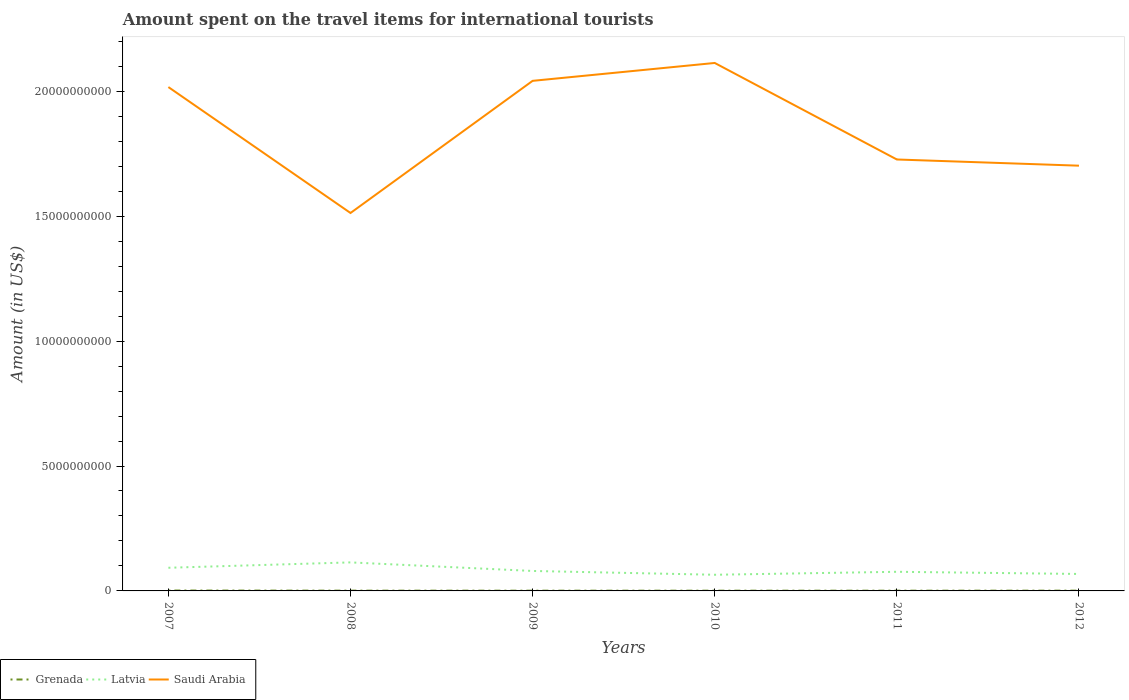Is the number of lines equal to the number of legend labels?
Ensure brevity in your answer.  Yes. Across all years, what is the maximum amount spent on the travel items for international tourists in Latvia?
Your response must be concise. 6.47e+08. In which year was the amount spent on the travel items for international tourists in Latvia maximum?
Provide a short and direct response. 2010. What is the total amount spent on the travel items for international tourists in Saudi Arabia in the graph?
Your response must be concise. -6.01e+09. What is the difference between the highest and the second highest amount spent on the travel items for international tourists in Grenada?
Offer a very short reply. 6.00e+06. What is the difference between the highest and the lowest amount spent on the travel items for international tourists in Grenada?
Your response must be concise. 1. How many lines are there?
Provide a short and direct response. 3. How many years are there in the graph?
Provide a short and direct response. 6. What is the difference between two consecutive major ticks on the Y-axis?
Your answer should be very brief. 5.00e+09. Are the values on the major ticks of Y-axis written in scientific E-notation?
Your answer should be compact. No. Does the graph contain any zero values?
Give a very brief answer. No. What is the title of the graph?
Offer a very short reply. Amount spent on the travel items for international tourists. What is the label or title of the X-axis?
Offer a terse response. Years. What is the label or title of the Y-axis?
Make the answer very short. Amount (in US$). What is the Amount (in US$) of Grenada in 2007?
Offer a very short reply. 1.60e+07. What is the Amount (in US$) in Latvia in 2007?
Ensure brevity in your answer.  9.27e+08. What is the Amount (in US$) in Saudi Arabia in 2007?
Give a very brief answer. 2.02e+1. What is the Amount (in US$) in Grenada in 2008?
Your answer should be compact. 1.10e+07. What is the Amount (in US$) of Latvia in 2008?
Offer a very short reply. 1.14e+09. What is the Amount (in US$) in Saudi Arabia in 2008?
Provide a succinct answer. 1.51e+1. What is the Amount (in US$) of Latvia in 2009?
Your answer should be very brief. 7.99e+08. What is the Amount (in US$) of Saudi Arabia in 2009?
Offer a very short reply. 2.04e+1. What is the Amount (in US$) in Latvia in 2010?
Keep it short and to the point. 6.47e+08. What is the Amount (in US$) in Saudi Arabia in 2010?
Provide a short and direct response. 2.11e+1. What is the Amount (in US$) in Latvia in 2011?
Ensure brevity in your answer.  7.66e+08. What is the Amount (in US$) of Saudi Arabia in 2011?
Your answer should be very brief. 1.73e+1. What is the Amount (in US$) of Grenada in 2012?
Your answer should be very brief. 1.10e+07. What is the Amount (in US$) of Latvia in 2012?
Ensure brevity in your answer.  6.79e+08. What is the Amount (in US$) of Saudi Arabia in 2012?
Your answer should be very brief. 1.70e+1. Across all years, what is the maximum Amount (in US$) of Grenada?
Keep it short and to the point. 1.60e+07. Across all years, what is the maximum Amount (in US$) in Latvia?
Offer a very short reply. 1.14e+09. Across all years, what is the maximum Amount (in US$) in Saudi Arabia?
Keep it short and to the point. 2.11e+1. Across all years, what is the minimum Amount (in US$) of Grenada?
Give a very brief answer. 1.00e+07. Across all years, what is the minimum Amount (in US$) of Latvia?
Your answer should be very brief. 6.47e+08. Across all years, what is the minimum Amount (in US$) in Saudi Arabia?
Give a very brief answer. 1.51e+1. What is the total Amount (in US$) of Grenada in the graph?
Your answer should be very brief. 6.80e+07. What is the total Amount (in US$) of Latvia in the graph?
Provide a short and direct response. 4.96e+09. What is the total Amount (in US$) in Saudi Arabia in the graph?
Your response must be concise. 1.11e+11. What is the difference between the Amount (in US$) in Grenada in 2007 and that in 2008?
Your answer should be very brief. 5.00e+06. What is the difference between the Amount (in US$) of Latvia in 2007 and that in 2008?
Offer a very short reply. -2.15e+08. What is the difference between the Amount (in US$) of Saudi Arabia in 2007 and that in 2008?
Give a very brief answer. 5.04e+09. What is the difference between the Amount (in US$) in Latvia in 2007 and that in 2009?
Make the answer very short. 1.28e+08. What is the difference between the Amount (in US$) in Saudi Arabia in 2007 and that in 2009?
Your response must be concise. -2.49e+08. What is the difference between the Amount (in US$) in Grenada in 2007 and that in 2010?
Provide a short and direct response. 6.00e+06. What is the difference between the Amount (in US$) in Latvia in 2007 and that in 2010?
Give a very brief answer. 2.80e+08. What is the difference between the Amount (in US$) in Saudi Arabia in 2007 and that in 2010?
Offer a very short reply. -9.65e+08. What is the difference between the Amount (in US$) of Grenada in 2007 and that in 2011?
Your answer should be compact. 6.00e+06. What is the difference between the Amount (in US$) in Latvia in 2007 and that in 2011?
Offer a very short reply. 1.61e+08. What is the difference between the Amount (in US$) of Saudi Arabia in 2007 and that in 2011?
Give a very brief answer. 2.90e+09. What is the difference between the Amount (in US$) in Grenada in 2007 and that in 2012?
Your answer should be very brief. 5.00e+06. What is the difference between the Amount (in US$) in Latvia in 2007 and that in 2012?
Give a very brief answer. 2.48e+08. What is the difference between the Amount (in US$) in Saudi Arabia in 2007 and that in 2012?
Ensure brevity in your answer.  3.15e+09. What is the difference between the Amount (in US$) of Grenada in 2008 and that in 2009?
Offer a terse response. 1.00e+06. What is the difference between the Amount (in US$) in Latvia in 2008 and that in 2009?
Keep it short and to the point. 3.43e+08. What is the difference between the Amount (in US$) of Saudi Arabia in 2008 and that in 2009?
Your response must be concise. -5.29e+09. What is the difference between the Amount (in US$) of Grenada in 2008 and that in 2010?
Offer a very short reply. 1.00e+06. What is the difference between the Amount (in US$) in Latvia in 2008 and that in 2010?
Provide a short and direct response. 4.95e+08. What is the difference between the Amount (in US$) of Saudi Arabia in 2008 and that in 2010?
Your answer should be compact. -6.01e+09. What is the difference between the Amount (in US$) in Grenada in 2008 and that in 2011?
Keep it short and to the point. 1.00e+06. What is the difference between the Amount (in US$) of Latvia in 2008 and that in 2011?
Provide a short and direct response. 3.76e+08. What is the difference between the Amount (in US$) of Saudi Arabia in 2008 and that in 2011?
Your answer should be compact. -2.14e+09. What is the difference between the Amount (in US$) of Grenada in 2008 and that in 2012?
Offer a very short reply. 0. What is the difference between the Amount (in US$) in Latvia in 2008 and that in 2012?
Provide a succinct answer. 4.63e+08. What is the difference between the Amount (in US$) in Saudi Arabia in 2008 and that in 2012?
Ensure brevity in your answer.  -1.89e+09. What is the difference between the Amount (in US$) in Grenada in 2009 and that in 2010?
Offer a very short reply. 0. What is the difference between the Amount (in US$) in Latvia in 2009 and that in 2010?
Keep it short and to the point. 1.52e+08. What is the difference between the Amount (in US$) in Saudi Arabia in 2009 and that in 2010?
Provide a short and direct response. -7.16e+08. What is the difference between the Amount (in US$) of Grenada in 2009 and that in 2011?
Provide a short and direct response. 0. What is the difference between the Amount (in US$) in Latvia in 2009 and that in 2011?
Make the answer very short. 3.30e+07. What is the difference between the Amount (in US$) in Saudi Arabia in 2009 and that in 2011?
Your answer should be compact. 3.15e+09. What is the difference between the Amount (in US$) in Latvia in 2009 and that in 2012?
Your response must be concise. 1.20e+08. What is the difference between the Amount (in US$) of Saudi Arabia in 2009 and that in 2012?
Your answer should be compact. 3.40e+09. What is the difference between the Amount (in US$) of Latvia in 2010 and that in 2011?
Offer a very short reply. -1.19e+08. What is the difference between the Amount (in US$) in Saudi Arabia in 2010 and that in 2011?
Your answer should be compact. 3.86e+09. What is the difference between the Amount (in US$) in Latvia in 2010 and that in 2012?
Offer a very short reply. -3.20e+07. What is the difference between the Amount (in US$) in Saudi Arabia in 2010 and that in 2012?
Make the answer very short. 4.11e+09. What is the difference between the Amount (in US$) in Grenada in 2011 and that in 2012?
Offer a terse response. -1.00e+06. What is the difference between the Amount (in US$) in Latvia in 2011 and that in 2012?
Offer a terse response. 8.70e+07. What is the difference between the Amount (in US$) in Saudi Arabia in 2011 and that in 2012?
Keep it short and to the point. 2.48e+08. What is the difference between the Amount (in US$) of Grenada in 2007 and the Amount (in US$) of Latvia in 2008?
Ensure brevity in your answer.  -1.13e+09. What is the difference between the Amount (in US$) in Grenada in 2007 and the Amount (in US$) in Saudi Arabia in 2008?
Your answer should be compact. -1.51e+1. What is the difference between the Amount (in US$) in Latvia in 2007 and the Amount (in US$) in Saudi Arabia in 2008?
Provide a succinct answer. -1.42e+1. What is the difference between the Amount (in US$) of Grenada in 2007 and the Amount (in US$) of Latvia in 2009?
Ensure brevity in your answer.  -7.83e+08. What is the difference between the Amount (in US$) in Grenada in 2007 and the Amount (in US$) in Saudi Arabia in 2009?
Offer a terse response. -2.04e+1. What is the difference between the Amount (in US$) in Latvia in 2007 and the Amount (in US$) in Saudi Arabia in 2009?
Your answer should be very brief. -1.95e+1. What is the difference between the Amount (in US$) of Grenada in 2007 and the Amount (in US$) of Latvia in 2010?
Ensure brevity in your answer.  -6.31e+08. What is the difference between the Amount (in US$) in Grenada in 2007 and the Amount (in US$) in Saudi Arabia in 2010?
Your answer should be compact. -2.11e+1. What is the difference between the Amount (in US$) of Latvia in 2007 and the Amount (in US$) of Saudi Arabia in 2010?
Keep it short and to the point. -2.02e+1. What is the difference between the Amount (in US$) in Grenada in 2007 and the Amount (in US$) in Latvia in 2011?
Provide a short and direct response. -7.50e+08. What is the difference between the Amount (in US$) of Grenada in 2007 and the Amount (in US$) of Saudi Arabia in 2011?
Keep it short and to the point. -1.73e+1. What is the difference between the Amount (in US$) in Latvia in 2007 and the Amount (in US$) in Saudi Arabia in 2011?
Make the answer very short. -1.63e+1. What is the difference between the Amount (in US$) in Grenada in 2007 and the Amount (in US$) in Latvia in 2012?
Offer a terse response. -6.63e+08. What is the difference between the Amount (in US$) in Grenada in 2007 and the Amount (in US$) in Saudi Arabia in 2012?
Give a very brief answer. -1.70e+1. What is the difference between the Amount (in US$) in Latvia in 2007 and the Amount (in US$) in Saudi Arabia in 2012?
Your answer should be compact. -1.61e+1. What is the difference between the Amount (in US$) in Grenada in 2008 and the Amount (in US$) in Latvia in 2009?
Your answer should be compact. -7.88e+08. What is the difference between the Amount (in US$) in Grenada in 2008 and the Amount (in US$) in Saudi Arabia in 2009?
Make the answer very short. -2.04e+1. What is the difference between the Amount (in US$) in Latvia in 2008 and the Amount (in US$) in Saudi Arabia in 2009?
Your answer should be very brief. -1.93e+1. What is the difference between the Amount (in US$) of Grenada in 2008 and the Amount (in US$) of Latvia in 2010?
Give a very brief answer. -6.36e+08. What is the difference between the Amount (in US$) in Grenada in 2008 and the Amount (in US$) in Saudi Arabia in 2010?
Make the answer very short. -2.11e+1. What is the difference between the Amount (in US$) of Latvia in 2008 and the Amount (in US$) of Saudi Arabia in 2010?
Your response must be concise. -2.00e+1. What is the difference between the Amount (in US$) in Grenada in 2008 and the Amount (in US$) in Latvia in 2011?
Offer a terse response. -7.55e+08. What is the difference between the Amount (in US$) of Grenada in 2008 and the Amount (in US$) of Saudi Arabia in 2011?
Your answer should be compact. -1.73e+1. What is the difference between the Amount (in US$) of Latvia in 2008 and the Amount (in US$) of Saudi Arabia in 2011?
Your response must be concise. -1.61e+1. What is the difference between the Amount (in US$) of Grenada in 2008 and the Amount (in US$) of Latvia in 2012?
Your response must be concise. -6.68e+08. What is the difference between the Amount (in US$) of Grenada in 2008 and the Amount (in US$) of Saudi Arabia in 2012?
Keep it short and to the point. -1.70e+1. What is the difference between the Amount (in US$) in Latvia in 2008 and the Amount (in US$) in Saudi Arabia in 2012?
Give a very brief answer. -1.59e+1. What is the difference between the Amount (in US$) in Grenada in 2009 and the Amount (in US$) in Latvia in 2010?
Offer a very short reply. -6.37e+08. What is the difference between the Amount (in US$) in Grenada in 2009 and the Amount (in US$) in Saudi Arabia in 2010?
Ensure brevity in your answer.  -2.11e+1. What is the difference between the Amount (in US$) in Latvia in 2009 and the Amount (in US$) in Saudi Arabia in 2010?
Provide a short and direct response. -2.03e+1. What is the difference between the Amount (in US$) in Grenada in 2009 and the Amount (in US$) in Latvia in 2011?
Keep it short and to the point. -7.56e+08. What is the difference between the Amount (in US$) of Grenada in 2009 and the Amount (in US$) of Saudi Arabia in 2011?
Your answer should be compact. -1.73e+1. What is the difference between the Amount (in US$) in Latvia in 2009 and the Amount (in US$) in Saudi Arabia in 2011?
Offer a very short reply. -1.65e+1. What is the difference between the Amount (in US$) in Grenada in 2009 and the Amount (in US$) in Latvia in 2012?
Give a very brief answer. -6.69e+08. What is the difference between the Amount (in US$) of Grenada in 2009 and the Amount (in US$) of Saudi Arabia in 2012?
Your response must be concise. -1.70e+1. What is the difference between the Amount (in US$) in Latvia in 2009 and the Amount (in US$) in Saudi Arabia in 2012?
Your response must be concise. -1.62e+1. What is the difference between the Amount (in US$) in Grenada in 2010 and the Amount (in US$) in Latvia in 2011?
Provide a succinct answer. -7.56e+08. What is the difference between the Amount (in US$) in Grenada in 2010 and the Amount (in US$) in Saudi Arabia in 2011?
Your response must be concise. -1.73e+1. What is the difference between the Amount (in US$) of Latvia in 2010 and the Amount (in US$) of Saudi Arabia in 2011?
Your answer should be very brief. -1.66e+1. What is the difference between the Amount (in US$) of Grenada in 2010 and the Amount (in US$) of Latvia in 2012?
Offer a very short reply. -6.69e+08. What is the difference between the Amount (in US$) of Grenada in 2010 and the Amount (in US$) of Saudi Arabia in 2012?
Make the answer very short. -1.70e+1. What is the difference between the Amount (in US$) in Latvia in 2010 and the Amount (in US$) in Saudi Arabia in 2012?
Offer a terse response. -1.64e+1. What is the difference between the Amount (in US$) of Grenada in 2011 and the Amount (in US$) of Latvia in 2012?
Provide a succinct answer. -6.69e+08. What is the difference between the Amount (in US$) in Grenada in 2011 and the Amount (in US$) in Saudi Arabia in 2012?
Provide a short and direct response. -1.70e+1. What is the difference between the Amount (in US$) in Latvia in 2011 and the Amount (in US$) in Saudi Arabia in 2012?
Your answer should be compact. -1.63e+1. What is the average Amount (in US$) of Grenada per year?
Offer a terse response. 1.13e+07. What is the average Amount (in US$) of Latvia per year?
Your answer should be compact. 8.27e+08. What is the average Amount (in US$) in Saudi Arabia per year?
Give a very brief answer. 1.85e+1. In the year 2007, what is the difference between the Amount (in US$) in Grenada and Amount (in US$) in Latvia?
Keep it short and to the point. -9.11e+08. In the year 2007, what is the difference between the Amount (in US$) in Grenada and Amount (in US$) in Saudi Arabia?
Offer a terse response. -2.02e+1. In the year 2007, what is the difference between the Amount (in US$) of Latvia and Amount (in US$) of Saudi Arabia?
Your response must be concise. -1.92e+1. In the year 2008, what is the difference between the Amount (in US$) of Grenada and Amount (in US$) of Latvia?
Ensure brevity in your answer.  -1.13e+09. In the year 2008, what is the difference between the Amount (in US$) in Grenada and Amount (in US$) in Saudi Arabia?
Ensure brevity in your answer.  -1.51e+1. In the year 2008, what is the difference between the Amount (in US$) of Latvia and Amount (in US$) of Saudi Arabia?
Offer a terse response. -1.40e+1. In the year 2009, what is the difference between the Amount (in US$) of Grenada and Amount (in US$) of Latvia?
Your answer should be very brief. -7.89e+08. In the year 2009, what is the difference between the Amount (in US$) in Grenada and Amount (in US$) in Saudi Arabia?
Your answer should be compact. -2.04e+1. In the year 2009, what is the difference between the Amount (in US$) in Latvia and Amount (in US$) in Saudi Arabia?
Keep it short and to the point. -1.96e+1. In the year 2010, what is the difference between the Amount (in US$) of Grenada and Amount (in US$) of Latvia?
Keep it short and to the point. -6.37e+08. In the year 2010, what is the difference between the Amount (in US$) of Grenada and Amount (in US$) of Saudi Arabia?
Ensure brevity in your answer.  -2.11e+1. In the year 2010, what is the difference between the Amount (in US$) of Latvia and Amount (in US$) of Saudi Arabia?
Provide a succinct answer. -2.05e+1. In the year 2011, what is the difference between the Amount (in US$) of Grenada and Amount (in US$) of Latvia?
Your response must be concise. -7.56e+08. In the year 2011, what is the difference between the Amount (in US$) in Grenada and Amount (in US$) in Saudi Arabia?
Provide a succinct answer. -1.73e+1. In the year 2011, what is the difference between the Amount (in US$) of Latvia and Amount (in US$) of Saudi Arabia?
Offer a very short reply. -1.65e+1. In the year 2012, what is the difference between the Amount (in US$) of Grenada and Amount (in US$) of Latvia?
Make the answer very short. -6.68e+08. In the year 2012, what is the difference between the Amount (in US$) of Grenada and Amount (in US$) of Saudi Arabia?
Provide a short and direct response. -1.70e+1. In the year 2012, what is the difference between the Amount (in US$) in Latvia and Amount (in US$) in Saudi Arabia?
Offer a terse response. -1.63e+1. What is the ratio of the Amount (in US$) in Grenada in 2007 to that in 2008?
Provide a short and direct response. 1.45. What is the ratio of the Amount (in US$) of Latvia in 2007 to that in 2008?
Your answer should be very brief. 0.81. What is the ratio of the Amount (in US$) in Saudi Arabia in 2007 to that in 2008?
Provide a succinct answer. 1.33. What is the ratio of the Amount (in US$) of Grenada in 2007 to that in 2009?
Your response must be concise. 1.6. What is the ratio of the Amount (in US$) of Latvia in 2007 to that in 2009?
Your answer should be very brief. 1.16. What is the ratio of the Amount (in US$) in Grenada in 2007 to that in 2010?
Ensure brevity in your answer.  1.6. What is the ratio of the Amount (in US$) of Latvia in 2007 to that in 2010?
Make the answer very short. 1.43. What is the ratio of the Amount (in US$) in Saudi Arabia in 2007 to that in 2010?
Make the answer very short. 0.95. What is the ratio of the Amount (in US$) in Grenada in 2007 to that in 2011?
Make the answer very short. 1.6. What is the ratio of the Amount (in US$) of Latvia in 2007 to that in 2011?
Offer a terse response. 1.21. What is the ratio of the Amount (in US$) in Saudi Arabia in 2007 to that in 2011?
Your response must be concise. 1.17. What is the ratio of the Amount (in US$) of Grenada in 2007 to that in 2012?
Ensure brevity in your answer.  1.45. What is the ratio of the Amount (in US$) in Latvia in 2007 to that in 2012?
Give a very brief answer. 1.37. What is the ratio of the Amount (in US$) of Saudi Arabia in 2007 to that in 2012?
Provide a succinct answer. 1.18. What is the ratio of the Amount (in US$) of Grenada in 2008 to that in 2009?
Provide a succinct answer. 1.1. What is the ratio of the Amount (in US$) of Latvia in 2008 to that in 2009?
Keep it short and to the point. 1.43. What is the ratio of the Amount (in US$) in Saudi Arabia in 2008 to that in 2009?
Give a very brief answer. 0.74. What is the ratio of the Amount (in US$) in Latvia in 2008 to that in 2010?
Your answer should be compact. 1.77. What is the ratio of the Amount (in US$) in Saudi Arabia in 2008 to that in 2010?
Provide a short and direct response. 0.72. What is the ratio of the Amount (in US$) in Grenada in 2008 to that in 2011?
Offer a terse response. 1.1. What is the ratio of the Amount (in US$) of Latvia in 2008 to that in 2011?
Give a very brief answer. 1.49. What is the ratio of the Amount (in US$) in Saudi Arabia in 2008 to that in 2011?
Ensure brevity in your answer.  0.88. What is the ratio of the Amount (in US$) in Latvia in 2008 to that in 2012?
Your response must be concise. 1.68. What is the ratio of the Amount (in US$) in Saudi Arabia in 2008 to that in 2012?
Give a very brief answer. 0.89. What is the ratio of the Amount (in US$) of Grenada in 2009 to that in 2010?
Offer a very short reply. 1. What is the ratio of the Amount (in US$) in Latvia in 2009 to that in 2010?
Offer a very short reply. 1.23. What is the ratio of the Amount (in US$) of Saudi Arabia in 2009 to that in 2010?
Your answer should be compact. 0.97. What is the ratio of the Amount (in US$) in Latvia in 2009 to that in 2011?
Keep it short and to the point. 1.04. What is the ratio of the Amount (in US$) of Saudi Arabia in 2009 to that in 2011?
Your answer should be very brief. 1.18. What is the ratio of the Amount (in US$) of Latvia in 2009 to that in 2012?
Ensure brevity in your answer.  1.18. What is the ratio of the Amount (in US$) in Saudi Arabia in 2009 to that in 2012?
Keep it short and to the point. 1.2. What is the ratio of the Amount (in US$) of Grenada in 2010 to that in 2011?
Your response must be concise. 1. What is the ratio of the Amount (in US$) of Latvia in 2010 to that in 2011?
Keep it short and to the point. 0.84. What is the ratio of the Amount (in US$) of Saudi Arabia in 2010 to that in 2011?
Provide a short and direct response. 1.22. What is the ratio of the Amount (in US$) in Grenada in 2010 to that in 2012?
Your answer should be very brief. 0.91. What is the ratio of the Amount (in US$) of Latvia in 2010 to that in 2012?
Make the answer very short. 0.95. What is the ratio of the Amount (in US$) in Saudi Arabia in 2010 to that in 2012?
Provide a short and direct response. 1.24. What is the ratio of the Amount (in US$) of Latvia in 2011 to that in 2012?
Make the answer very short. 1.13. What is the ratio of the Amount (in US$) in Saudi Arabia in 2011 to that in 2012?
Your answer should be compact. 1.01. What is the difference between the highest and the second highest Amount (in US$) of Latvia?
Your response must be concise. 2.15e+08. What is the difference between the highest and the second highest Amount (in US$) in Saudi Arabia?
Provide a succinct answer. 7.16e+08. What is the difference between the highest and the lowest Amount (in US$) in Grenada?
Your answer should be very brief. 6.00e+06. What is the difference between the highest and the lowest Amount (in US$) of Latvia?
Your answer should be very brief. 4.95e+08. What is the difference between the highest and the lowest Amount (in US$) in Saudi Arabia?
Ensure brevity in your answer.  6.01e+09. 